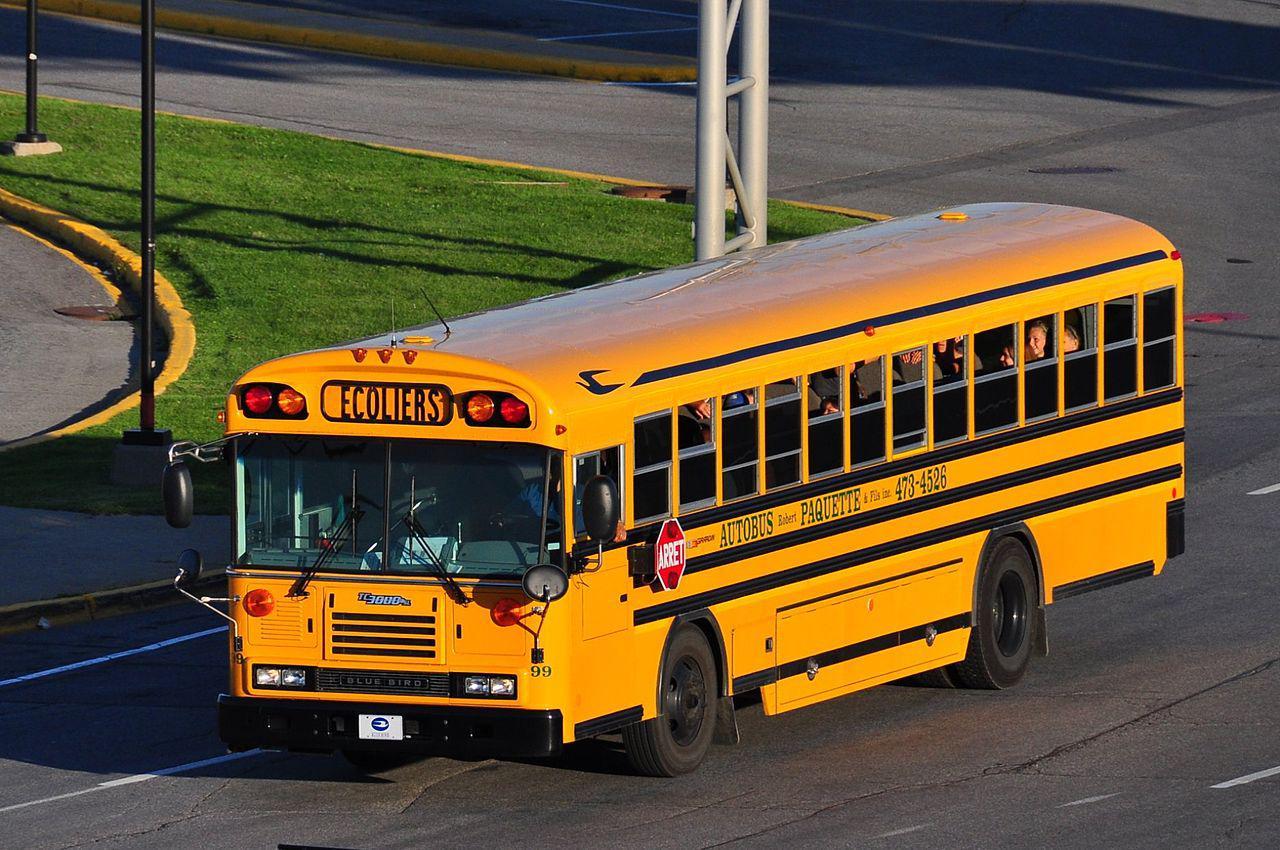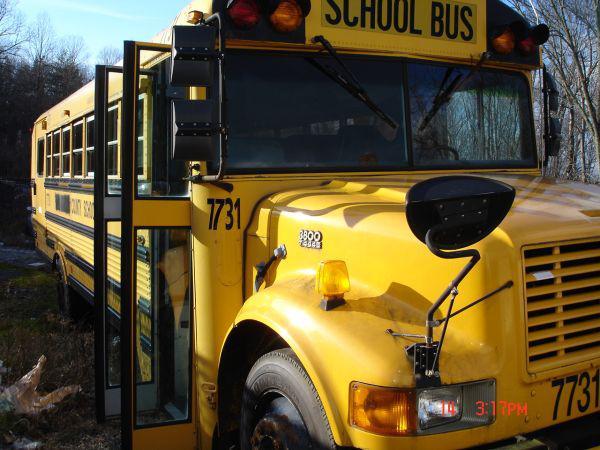The first image is the image on the left, the second image is the image on the right. Examine the images to the left and right. Is the description "In one of the images, the bus passenger door is open." accurate? Answer yes or no. Yes. The first image is the image on the left, the second image is the image on the right. For the images shown, is this caption "The right image shows a leftward-angled non-flat bus, and the left image shows the front of a parked non-flat bus that has only one hood and grille and has a license plate on its front bumper." true? Answer yes or no. No. 